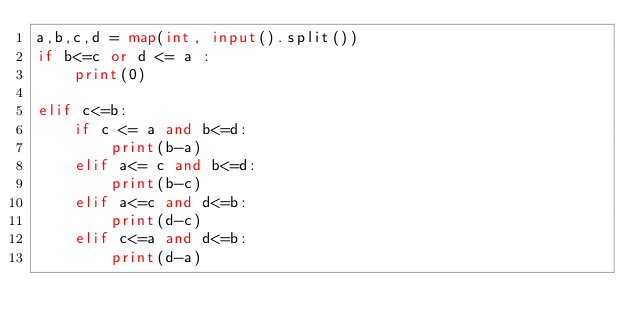Convert code to text. <code><loc_0><loc_0><loc_500><loc_500><_Python_>a,b,c,d = map(int, input().split())
if b<=c or d <= a :
    print(0)
    
elif c<=b:
    if c <= a and b<=d:
        print(b-a)
    elif a<= c and b<=d:
        print(b-c)
    elif a<=c and d<=b:
        print(d-c)
    elif c<=a and d<=b:
        print(d-a)</code> 